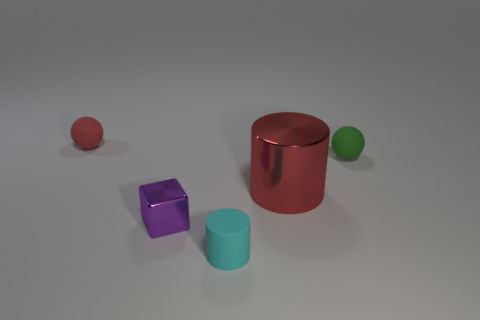How many things are to the left of the large red metallic object and in front of the small red object?
Offer a terse response. 2. What is the material of the green thing?
Ensure brevity in your answer.  Rubber. Are there an equal number of red objects behind the small red sphere and small purple rubber cylinders?
Provide a short and direct response. Yes. What number of small red things are the same shape as the green rubber thing?
Your answer should be very brief. 1. Does the green rubber thing have the same shape as the small shiny thing?
Your answer should be very brief. No. What number of things are either rubber things left of the big red cylinder or large gray matte things?
Give a very brief answer. 2. What is the shape of the tiny rubber thing that is in front of the small ball on the right side of the matte thing that is left of the tiny purple metallic thing?
Provide a short and direct response. Cylinder. The tiny red object that is made of the same material as the green sphere is what shape?
Offer a very short reply. Sphere. The purple shiny thing has what size?
Offer a very short reply. Small. Is the size of the purple block the same as the red cylinder?
Offer a very short reply. No. 